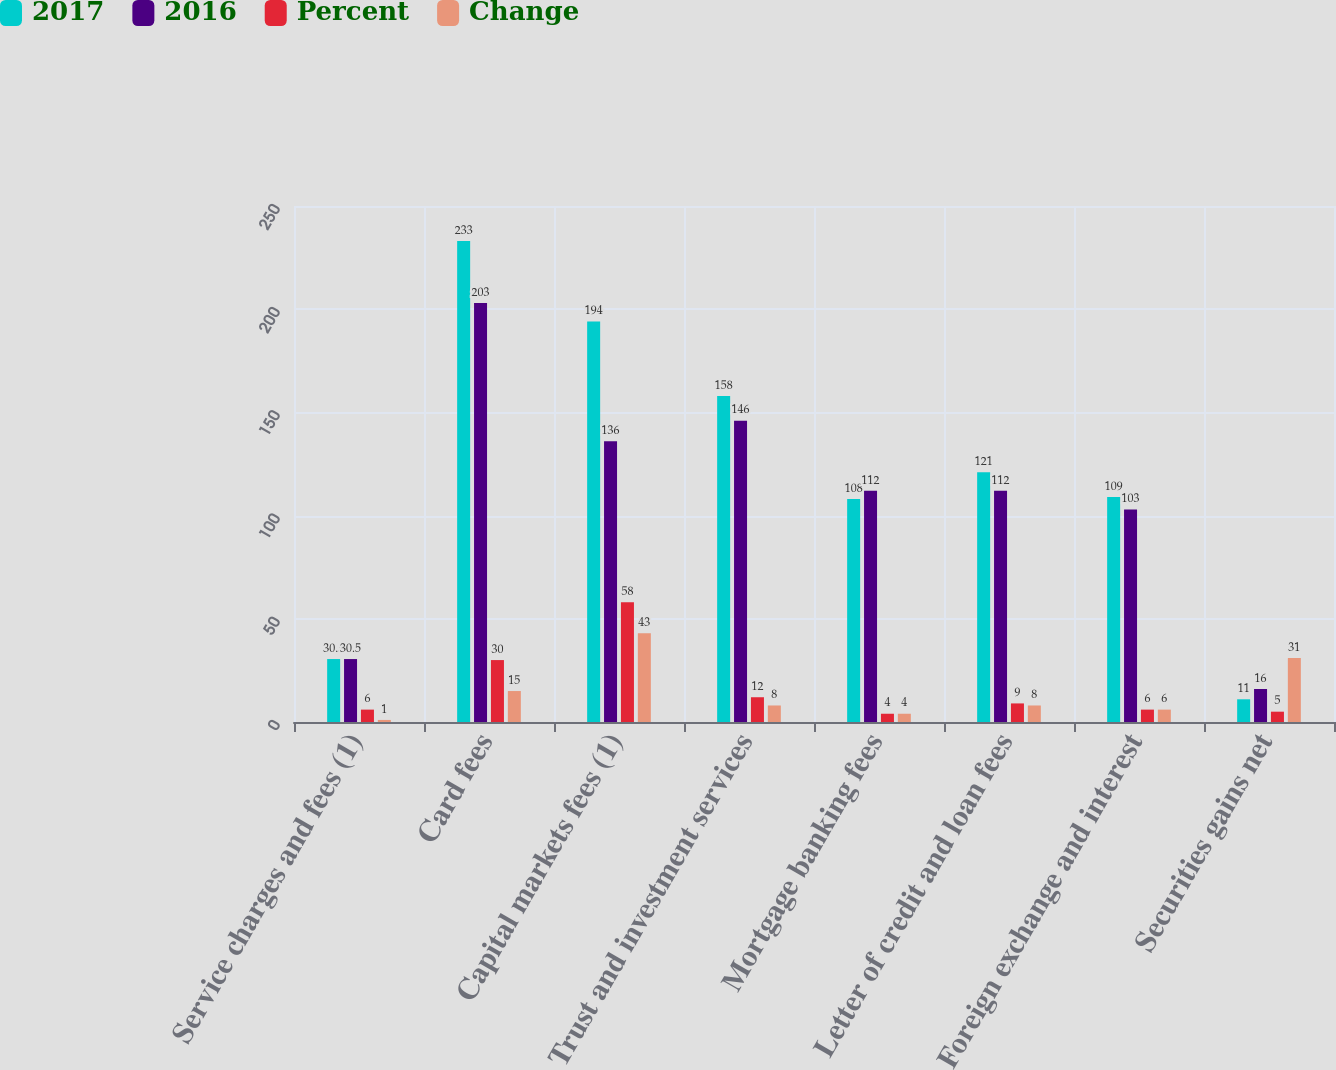<chart> <loc_0><loc_0><loc_500><loc_500><stacked_bar_chart><ecel><fcel>Service charges and fees (1)<fcel>Card fees<fcel>Capital markets fees (1)<fcel>Trust and investment services<fcel>Mortgage banking fees<fcel>Letter of credit and loan fees<fcel>Foreign exchange and interest<fcel>Securities gains net<nl><fcel>2017<fcel>30.5<fcel>233<fcel>194<fcel>158<fcel>108<fcel>121<fcel>109<fcel>11<nl><fcel>2016<fcel>30.5<fcel>203<fcel>136<fcel>146<fcel>112<fcel>112<fcel>103<fcel>16<nl><fcel>Percent<fcel>6<fcel>30<fcel>58<fcel>12<fcel>4<fcel>9<fcel>6<fcel>5<nl><fcel>Change<fcel>1<fcel>15<fcel>43<fcel>8<fcel>4<fcel>8<fcel>6<fcel>31<nl></chart> 